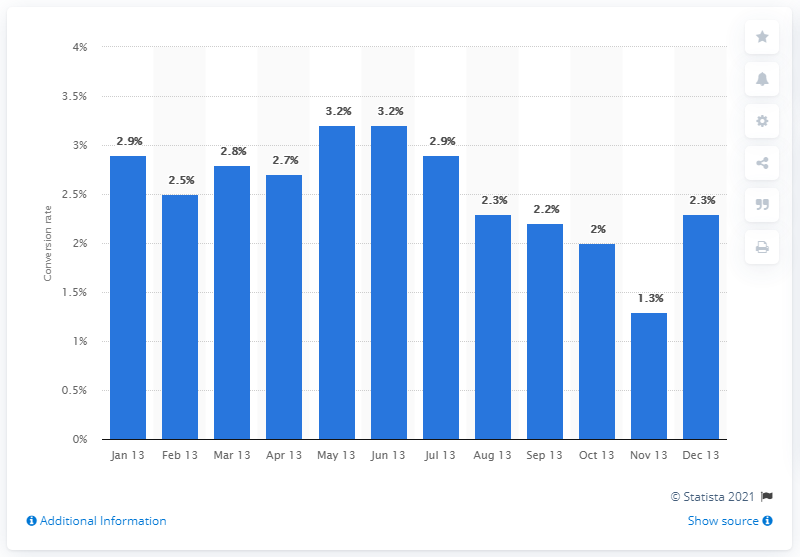Highlight a few significant elements in this photo. The conversion rate in December 2013 was 2.3%. 